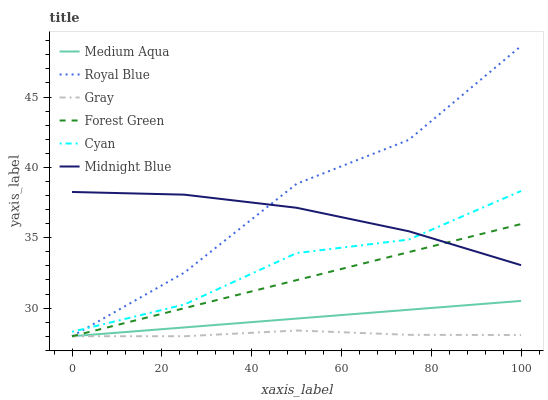Does Midnight Blue have the minimum area under the curve?
Answer yes or no. No. Does Midnight Blue have the maximum area under the curve?
Answer yes or no. No. Is Midnight Blue the smoothest?
Answer yes or no. No. Is Midnight Blue the roughest?
Answer yes or no. No. Does Midnight Blue have the lowest value?
Answer yes or no. No. Does Midnight Blue have the highest value?
Answer yes or no. No. Is Gray less than Midnight Blue?
Answer yes or no. Yes. Is Midnight Blue greater than Gray?
Answer yes or no. Yes. Does Gray intersect Midnight Blue?
Answer yes or no. No. 